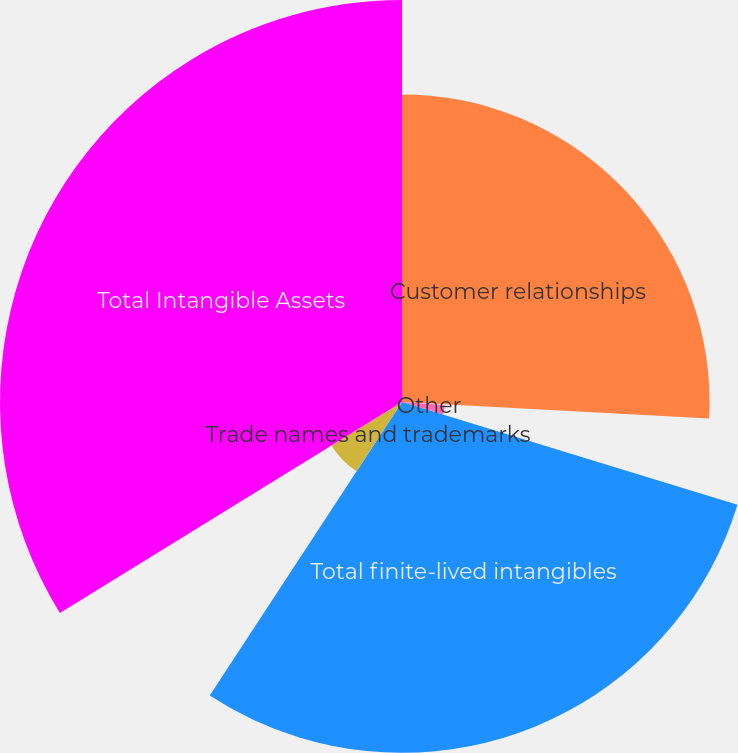<chart> <loc_0><loc_0><loc_500><loc_500><pie_chart><fcel>Customer relationships<fcel>Patents and technology<fcel>Other<fcel>Total finite-lived intangibles<fcel>Trade names and trademarks<fcel>Total Intangible Assets<nl><fcel>25.86%<fcel>0.26%<fcel>3.61%<fcel>29.5%<fcel>6.97%<fcel>33.8%<nl></chart> 